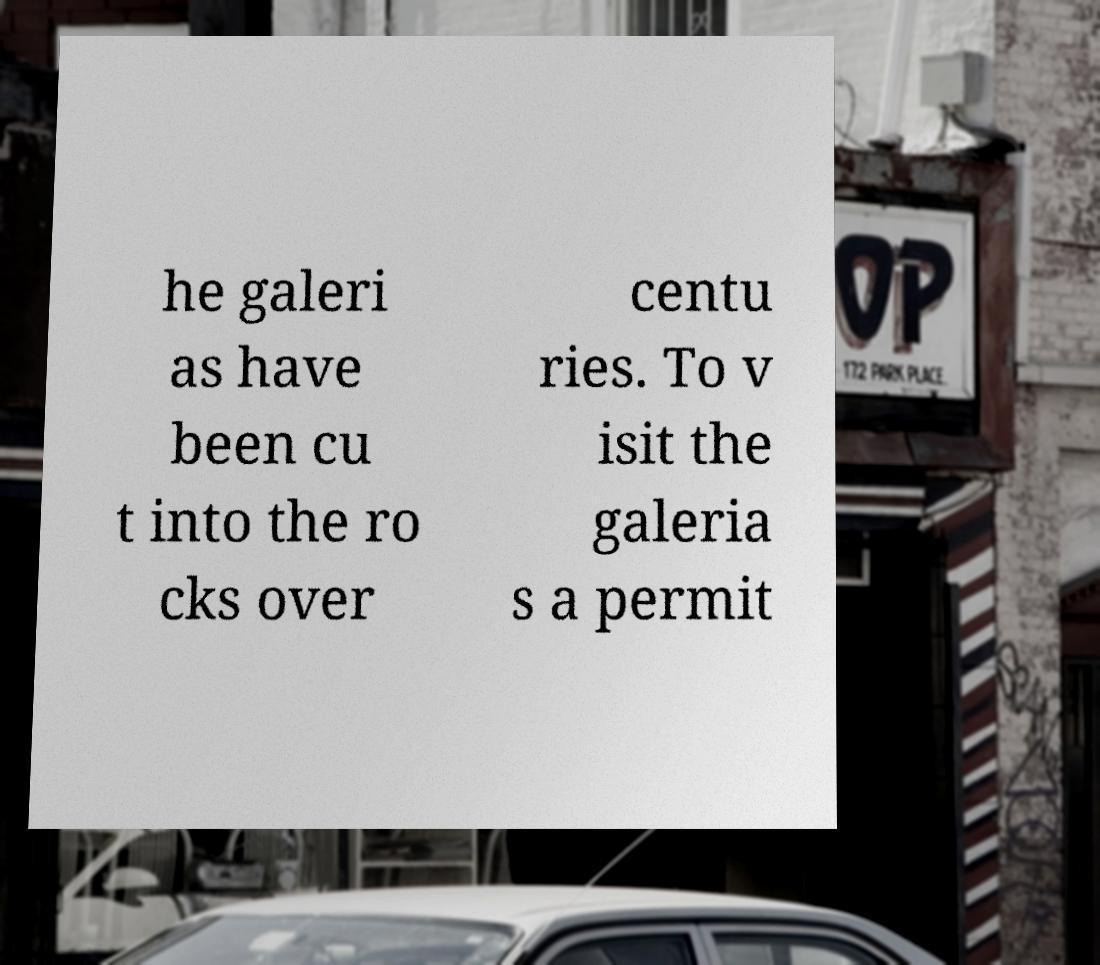I need the written content from this picture converted into text. Can you do that? he galeri as have been cu t into the ro cks over centu ries. To v isit the galeria s a permit 